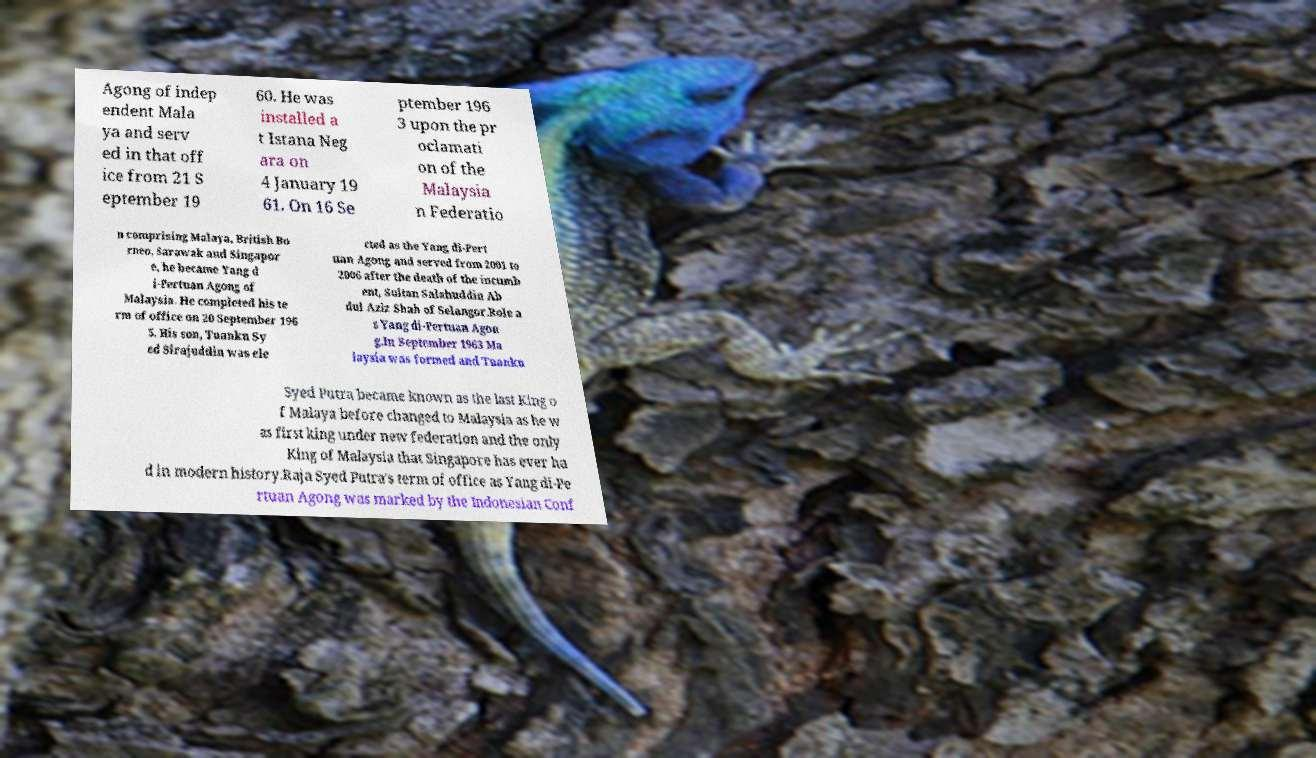Can you accurately transcribe the text from the provided image for me? Agong of indep endent Mala ya and serv ed in that off ice from 21 S eptember 19 60. He was installed a t Istana Neg ara on 4 January 19 61. On 16 Se ptember 196 3 upon the pr oclamati on of the Malaysia n Federatio n comprising Malaya, British Bo rneo, Sarawak and Singapor e, he became Yang d i-Pertuan Agong of Malaysia. He completed his te rm of office on 20 September 196 5. His son, Tuanku Sy ed Sirajuddin was ele cted as the Yang di-Pert uan Agong and served from 2001 to 2006 after the death of the incumb ent, Sultan Salahuddin Ab dul Aziz Shah of Selangor.Role a s Yang di-Pertuan Agon g.In September 1963 Ma laysia was formed and Tuanku Syed Putra became known as the last King o f Malaya before changed to Malaysia as he w as first king under new federation and the only King of Malaysia that Singapore has ever ha d in modern history.Raja Syed Putra's term of office as Yang di-Pe rtuan Agong was marked by the Indonesian Conf 